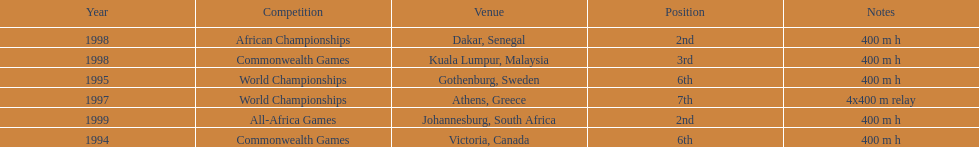What is the name of the last competition? All-Africa Games. 